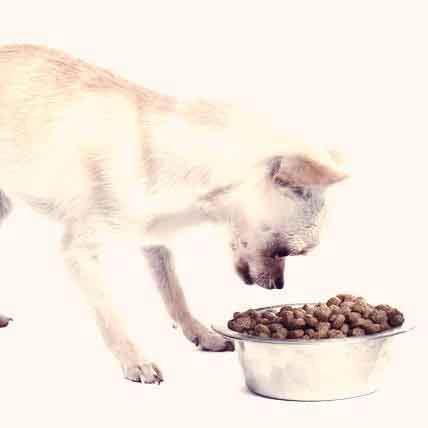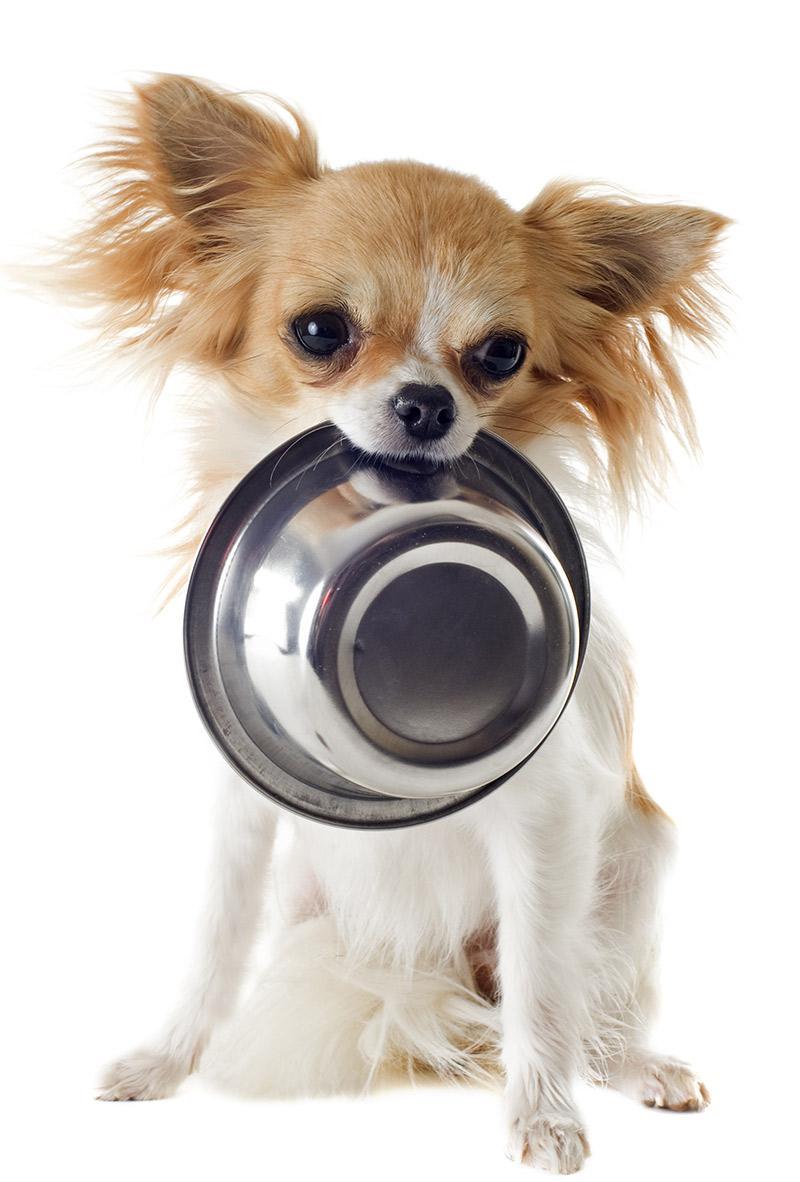The first image is the image on the left, the second image is the image on the right. Considering the images on both sides, is "The left image shows a chihuahua with a fork handle in its mouth sitting behind food." valid? Answer yes or no. No. The first image is the image on the left, the second image is the image on the right. For the images displayed, is the sentence "The left image contains one dog that has a fork in its mouth." factually correct? Answer yes or no. No. 